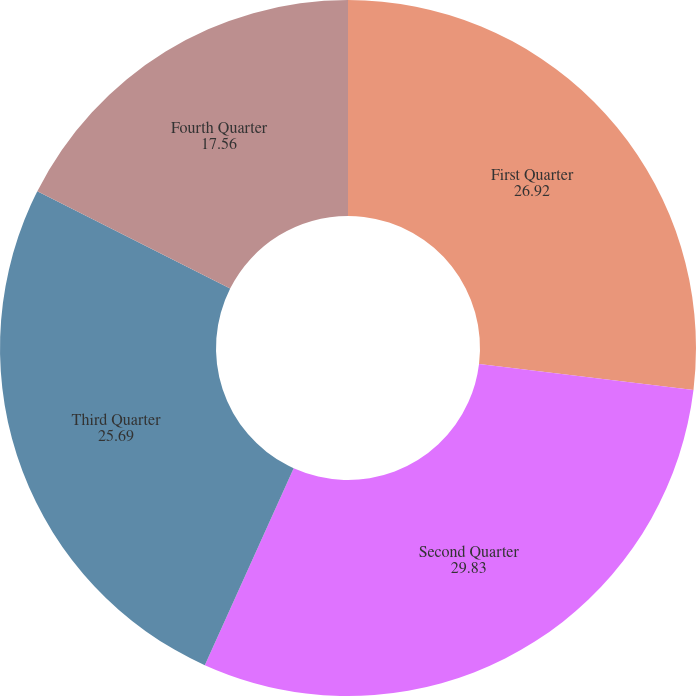Convert chart. <chart><loc_0><loc_0><loc_500><loc_500><pie_chart><fcel>First Quarter<fcel>Second Quarter<fcel>Third Quarter<fcel>Fourth Quarter<nl><fcel>26.92%<fcel>29.83%<fcel>25.69%<fcel>17.56%<nl></chart> 